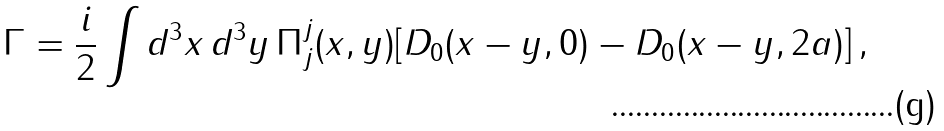<formula> <loc_0><loc_0><loc_500><loc_500>\Gamma = \frac { i } { 2 } \int d ^ { 3 } x \, d ^ { 3 } y \, \Pi _ { j } ^ { j } ( x , y ) [ D _ { 0 } ( x - y , 0 ) - D _ { 0 } ( x - y , 2 a ) ] \, ,</formula> 